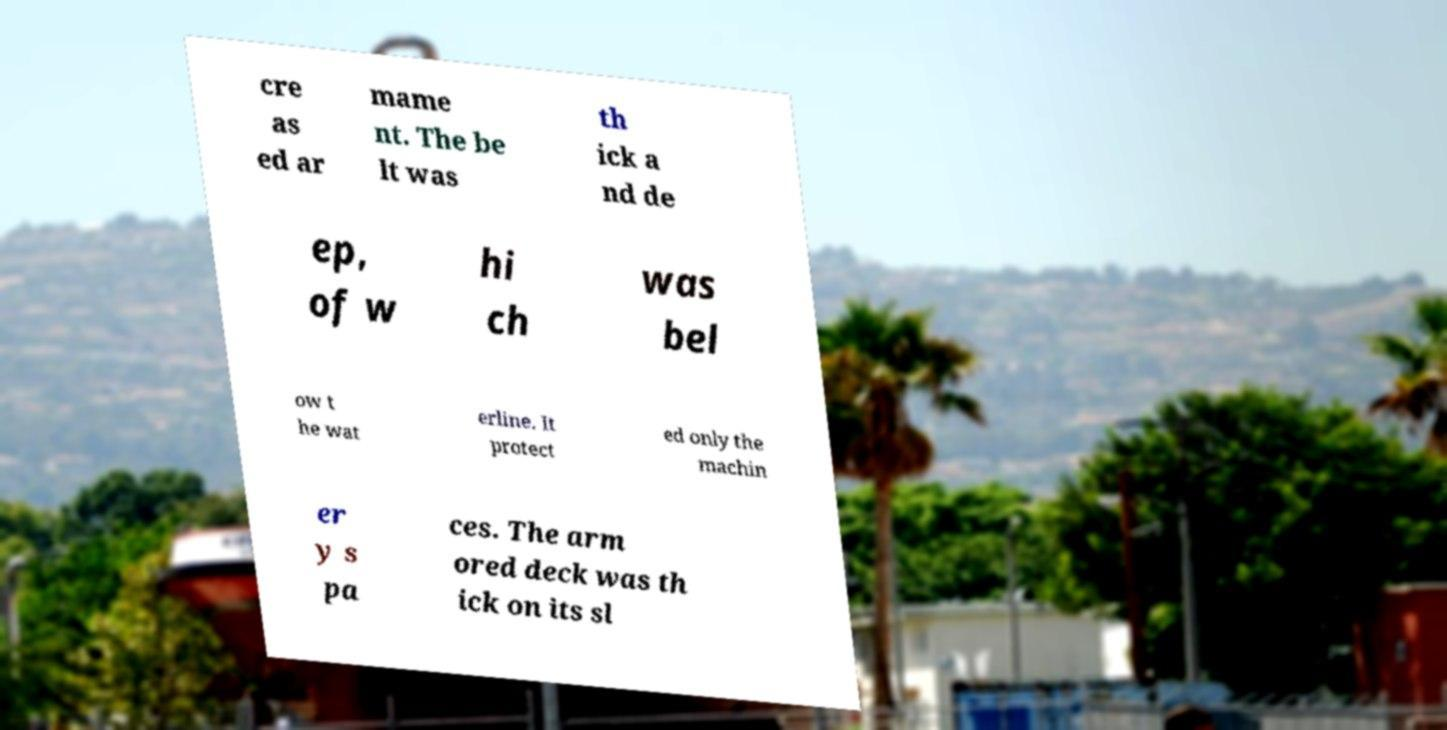I need the written content from this picture converted into text. Can you do that? cre as ed ar mame nt. The be lt was th ick a nd de ep, of w hi ch was bel ow t he wat erline. It protect ed only the machin er y s pa ces. The arm ored deck was th ick on its sl 